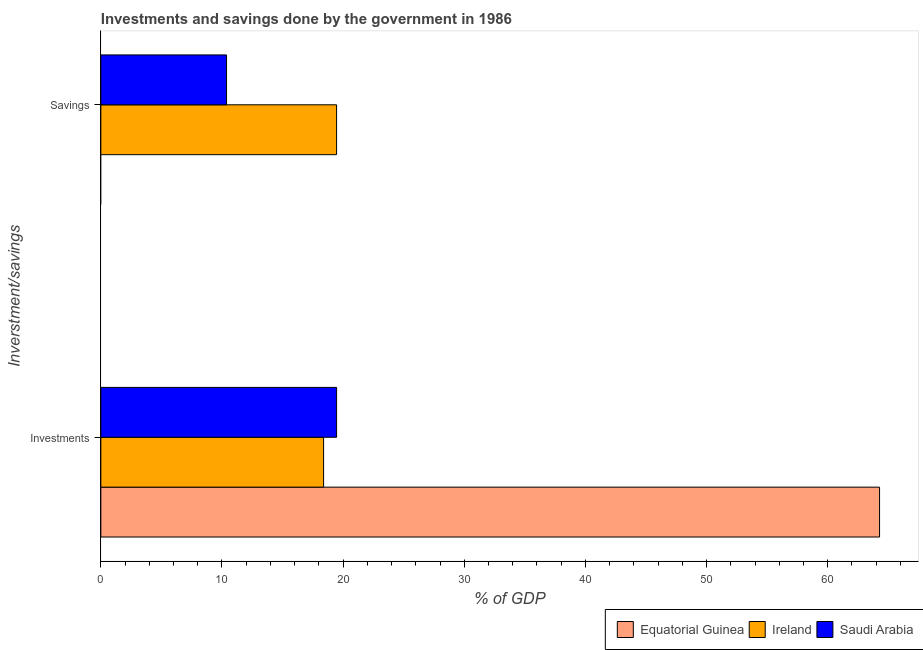How many different coloured bars are there?
Provide a short and direct response. 3. How many groups of bars are there?
Offer a very short reply. 2. What is the label of the 2nd group of bars from the top?
Provide a short and direct response. Investments. What is the savings of government in Ireland?
Your answer should be very brief. 19.46. Across all countries, what is the maximum savings of government?
Your answer should be very brief. 19.46. Across all countries, what is the minimum investments of government?
Provide a short and direct response. 18.39. In which country was the investments of government maximum?
Give a very brief answer. Equatorial Guinea. What is the total savings of government in the graph?
Provide a short and direct response. 29.83. What is the difference between the investments of government in Saudi Arabia and that in Ireland?
Make the answer very short. 1.07. What is the difference between the investments of government in Saudi Arabia and the savings of government in Equatorial Guinea?
Your answer should be very brief. 19.46. What is the average savings of government per country?
Provide a succinct answer. 9.94. What is the difference between the savings of government and investments of government in Saudi Arabia?
Keep it short and to the point. -9.08. In how many countries, is the savings of government greater than 40 %?
Provide a short and direct response. 0. What is the ratio of the savings of government in Saudi Arabia to that in Ireland?
Give a very brief answer. 0.53. In how many countries, is the investments of government greater than the average investments of government taken over all countries?
Keep it short and to the point. 1. Are the values on the major ticks of X-axis written in scientific E-notation?
Provide a short and direct response. No. How many legend labels are there?
Your answer should be very brief. 3. How are the legend labels stacked?
Your answer should be very brief. Horizontal. What is the title of the graph?
Make the answer very short. Investments and savings done by the government in 1986. What is the label or title of the X-axis?
Your answer should be very brief. % of GDP. What is the label or title of the Y-axis?
Provide a succinct answer. Inverstment/savings. What is the % of GDP of Equatorial Guinea in Investments?
Offer a terse response. 64.28. What is the % of GDP in Ireland in Investments?
Your response must be concise. 18.39. What is the % of GDP in Saudi Arabia in Investments?
Your answer should be compact. 19.46. What is the % of GDP of Equatorial Guinea in Savings?
Provide a short and direct response. 0. What is the % of GDP in Ireland in Savings?
Provide a short and direct response. 19.46. What is the % of GDP in Saudi Arabia in Savings?
Your answer should be compact. 10.38. Across all Inverstment/savings, what is the maximum % of GDP in Equatorial Guinea?
Your answer should be compact. 64.28. Across all Inverstment/savings, what is the maximum % of GDP in Ireland?
Offer a very short reply. 19.46. Across all Inverstment/savings, what is the maximum % of GDP in Saudi Arabia?
Ensure brevity in your answer.  19.46. Across all Inverstment/savings, what is the minimum % of GDP in Equatorial Guinea?
Make the answer very short. 0. Across all Inverstment/savings, what is the minimum % of GDP of Ireland?
Give a very brief answer. 18.39. Across all Inverstment/savings, what is the minimum % of GDP of Saudi Arabia?
Ensure brevity in your answer.  10.38. What is the total % of GDP of Equatorial Guinea in the graph?
Ensure brevity in your answer.  64.28. What is the total % of GDP in Ireland in the graph?
Ensure brevity in your answer.  37.84. What is the total % of GDP of Saudi Arabia in the graph?
Your response must be concise. 29.84. What is the difference between the % of GDP in Ireland in Investments and that in Savings?
Make the answer very short. -1.07. What is the difference between the % of GDP in Saudi Arabia in Investments and that in Savings?
Provide a succinct answer. 9.08. What is the difference between the % of GDP in Equatorial Guinea in Investments and the % of GDP in Ireland in Savings?
Your answer should be very brief. 44.82. What is the difference between the % of GDP in Equatorial Guinea in Investments and the % of GDP in Saudi Arabia in Savings?
Offer a terse response. 53.9. What is the difference between the % of GDP in Ireland in Investments and the % of GDP in Saudi Arabia in Savings?
Make the answer very short. 8.01. What is the average % of GDP in Equatorial Guinea per Inverstment/savings?
Provide a short and direct response. 32.14. What is the average % of GDP of Ireland per Inverstment/savings?
Provide a short and direct response. 18.92. What is the average % of GDP in Saudi Arabia per Inverstment/savings?
Provide a succinct answer. 14.92. What is the difference between the % of GDP in Equatorial Guinea and % of GDP in Ireland in Investments?
Provide a short and direct response. 45.89. What is the difference between the % of GDP in Equatorial Guinea and % of GDP in Saudi Arabia in Investments?
Provide a succinct answer. 44.82. What is the difference between the % of GDP in Ireland and % of GDP in Saudi Arabia in Investments?
Keep it short and to the point. -1.07. What is the difference between the % of GDP in Ireland and % of GDP in Saudi Arabia in Savings?
Make the answer very short. 9.08. What is the ratio of the % of GDP of Ireland in Investments to that in Savings?
Keep it short and to the point. 0.94. What is the ratio of the % of GDP in Saudi Arabia in Investments to that in Savings?
Make the answer very short. 1.88. What is the difference between the highest and the second highest % of GDP of Ireland?
Your answer should be compact. 1.07. What is the difference between the highest and the second highest % of GDP of Saudi Arabia?
Provide a succinct answer. 9.08. What is the difference between the highest and the lowest % of GDP in Equatorial Guinea?
Make the answer very short. 64.28. What is the difference between the highest and the lowest % of GDP in Ireland?
Keep it short and to the point. 1.07. What is the difference between the highest and the lowest % of GDP of Saudi Arabia?
Offer a terse response. 9.08. 